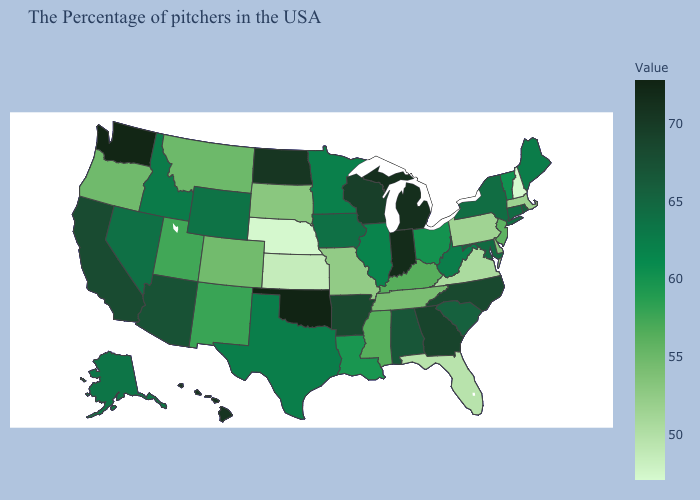Among the states that border New Jersey , which have the highest value?
Write a very short answer. New York. Does Georgia have the lowest value in the South?
Quick response, please. No. Is the legend a continuous bar?
Answer briefly. Yes. Among the states that border Maryland , does West Virginia have the lowest value?
Answer briefly. No. Does Connecticut have a higher value than North Carolina?
Give a very brief answer. No. Does Oklahoma have the highest value in the USA?
Write a very short answer. Yes. Does the map have missing data?
Quick response, please. No. Does New Hampshire have the lowest value in the USA?
Give a very brief answer. Yes. Does Indiana have a lower value than Colorado?
Keep it brief. No. 